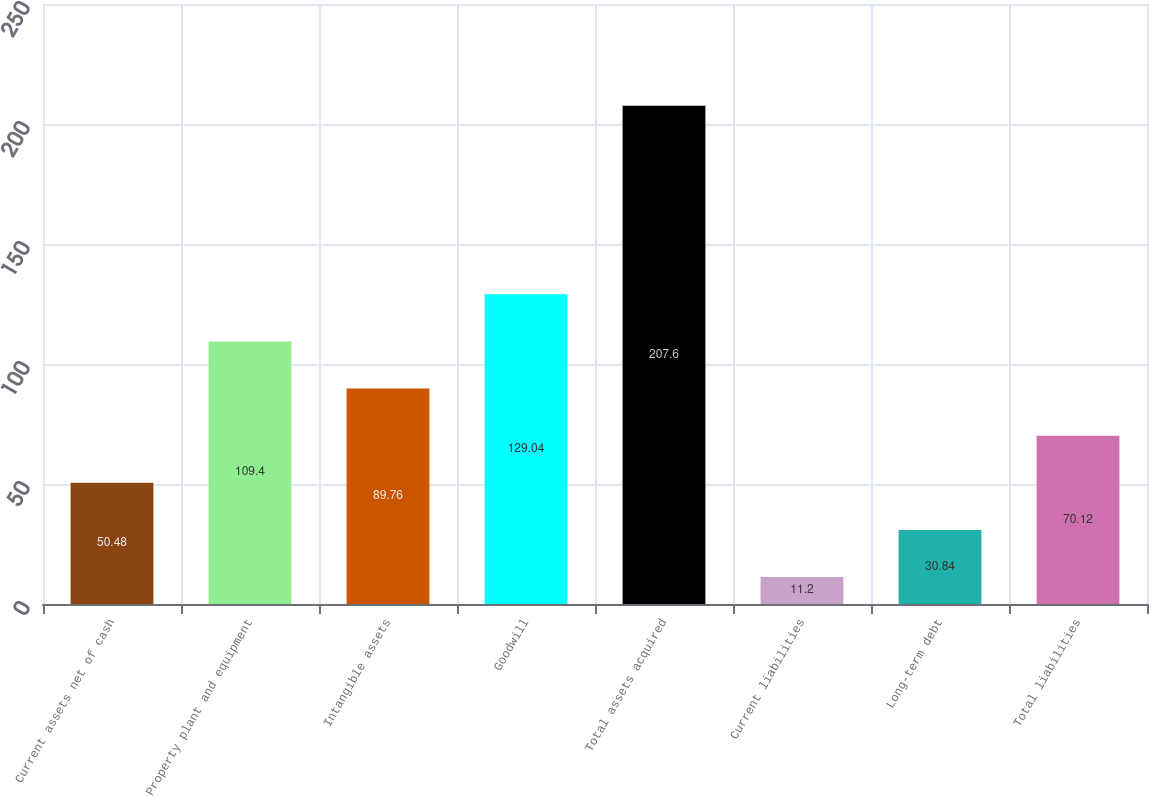Convert chart to OTSL. <chart><loc_0><loc_0><loc_500><loc_500><bar_chart><fcel>Current assets net of cash<fcel>Property plant and equipment<fcel>Intangible assets<fcel>Goodwill<fcel>Total assets acquired<fcel>Current liabilities<fcel>Long-term debt<fcel>Total liabilities<nl><fcel>50.48<fcel>109.4<fcel>89.76<fcel>129.04<fcel>207.6<fcel>11.2<fcel>30.84<fcel>70.12<nl></chart> 